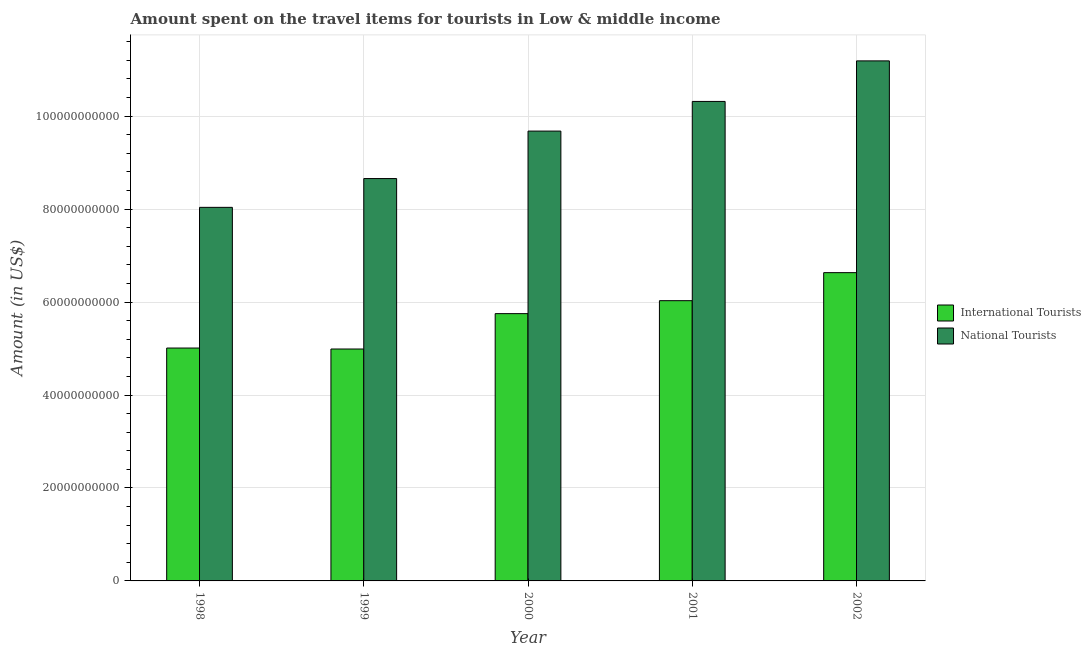What is the label of the 4th group of bars from the left?
Ensure brevity in your answer.  2001. What is the amount spent on travel items of international tourists in 2000?
Offer a terse response. 5.75e+1. Across all years, what is the maximum amount spent on travel items of national tourists?
Keep it short and to the point. 1.12e+11. Across all years, what is the minimum amount spent on travel items of international tourists?
Ensure brevity in your answer.  4.99e+1. In which year was the amount spent on travel items of national tourists minimum?
Offer a terse response. 1998. What is the total amount spent on travel items of international tourists in the graph?
Keep it short and to the point. 2.84e+11. What is the difference between the amount spent on travel items of international tourists in 2000 and that in 2001?
Give a very brief answer. -2.79e+09. What is the difference between the amount spent on travel items of national tourists in 2000 and the amount spent on travel items of international tourists in 2002?
Make the answer very short. -1.51e+1. What is the average amount spent on travel items of international tourists per year?
Provide a short and direct response. 5.68e+1. In the year 2000, what is the difference between the amount spent on travel items of international tourists and amount spent on travel items of national tourists?
Your answer should be very brief. 0. What is the ratio of the amount spent on travel items of national tourists in 1999 to that in 2000?
Offer a very short reply. 0.89. Is the difference between the amount spent on travel items of international tourists in 2000 and 2002 greater than the difference between the amount spent on travel items of national tourists in 2000 and 2002?
Offer a very short reply. No. What is the difference between the highest and the second highest amount spent on travel items of international tourists?
Offer a very short reply. 6.03e+09. What is the difference between the highest and the lowest amount spent on travel items of national tourists?
Offer a very short reply. 3.15e+1. Is the sum of the amount spent on travel items of international tourists in 2000 and 2002 greater than the maximum amount spent on travel items of national tourists across all years?
Your response must be concise. Yes. What does the 2nd bar from the left in 2001 represents?
Ensure brevity in your answer.  National Tourists. What does the 1st bar from the right in 2000 represents?
Make the answer very short. National Tourists. How many bars are there?
Provide a short and direct response. 10. Does the graph contain grids?
Provide a succinct answer. Yes. How are the legend labels stacked?
Your answer should be compact. Vertical. What is the title of the graph?
Your answer should be compact. Amount spent on the travel items for tourists in Low & middle income. What is the label or title of the X-axis?
Your answer should be compact. Year. What is the label or title of the Y-axis?
Make the answer very short. Amount (in US$). What is the Amount (in US$) of International Tourists in 1998?
Provide a short and direct response. 5.01e+1. What is the Amount (in US$) of National Tourists in 1998?
Your response must be concise. 8.04e+1. What is the Amount (in US$) of International Tourists in 1999?
Make the answer very short. 4.99e+1. What is the Amount (in US$) of National Tourists in 1999?
Your answer should be compact. 8.66e+1. What is the Amount (in US$) in International Tourists in 2000?
Offer a terse response. 5.75e+1. What is the Amount (in US$) of National Tourists in 2000?
Your response must be concise. 9.68e+1. What is the Amount (in US$) in International Tourists in 2001?
Make the answer very short. 6.03e+1. What is the Amount (in US$) in National Tourists in 2001?
Offer a very short reply. 1.03e+11. What is the Amount (in US$) in International Tourists in 2002?
Your answer should be compact. 6.63e+1. What is the Amount (in US$) of National Tourists in 2002?
Your answer should be compact. 1.12e+11. Across all years, what is the maximum Amount (in US$) in International Tourists?
Your response must be concise. 6.63e+1. Across all years, what is the maximum Amount (in US$) in National Tourists?
Your answer should be very brief. 1.12e+11. Across all years, what is the minimum Amount (in US$) in International Tourists?
Provide a short and direct response. 4.99e+1. Across all years, what is the minimum Amount (in US$) in National Tourists?
Your answer should be very brief. 8.04e+1. What is the total Amount (in US$) in International Tourists in the graph?
Ensure brevity in your answer.  2.84e+11. What is the total Amount (in US$) of National Tourists in the graph?
Your answer should be compact. 4.79e+11. What is the difference between the Amount (in US$) in International Tourists in 1998 and that in 1999?
Ensure brevity in your answer.  2.08e+08. What is the difference between the Amount (in US$) of National Tourists in 1998 and that in 1999?
Offer a very short reply. -6.20e+09. What is the difference between the Amount (in US$) in International Tourists in 1998 and that in 2000?
Provide a succinct answer. -7.40e+09. What is the difference between the Amount (in US$) of National Tourists in 1998 and that in 2000?
Provide a succinct answer. -1.64e+1. What is the difference between the Amount (in US$) of International Tourists in 1998 and that in 2001?
Your answer should be compact. -1.02e+1. What is the difference between the Amount (in US$) in National Tourists in 1998 and that in 2001?
Your answer should be compact. -2.28e+1. What is the difference between the Amount (in US$) in International Tourists in 1998 and that in 2002?
Offer a very short reply. -1.62e+1. What is the difference between the Amount (in US$) of National Tourists in 1998 and that in 2002?
Offer a very short reply. -3.15e+1. What is the difference between the Amount (in US$) in International Tourists in 1999 and that in 2000?
Make the answer very short. -7.61e+09. What is the difference between the Amount (in US$) in National Tourists in 1999 and that in 2000?
Keep it short and to the point. -1.02e+1. What is the difference between the Amount (in US$) in International Tourists in 1999 and that in 2001?
Offer a terse response. -1.04e+1. What is the difference between the Amount (in US$) of National Tourists in 1999 and that in 2001?
Your response must be concise. -1.66e+1. What is the difference between the Amount (in US$) in International Tourists in 1999 and that in 2002?
Your answer should be compact. -1.64e+1. What is the difference between the Amount (in US$) of National Tourists in 1999 and that in 2002?
Offer a terse response. -2.53e+1. What is the difference between the Amount (in US$) of International Tourists in 2000 and that in 2001?
Keep it short and to the point. -2.79e+09. What is the difference between the Amount (in US$) in National Tourists in 2000 and that in 2001?
Your response must be concise. -6.38e+09. What is the difference between the Amount (in US$) in International Tourists in 2000 and that in 2002?
Ensure brevity in your answer.  -8.82e+09. What is the difference between the Amount (in US$) of National Tourists in 2000 and that in 2002?
Offer a terse response. -1.51e+1. What is the difference between the Amount (in US$) in International Tourists in 2001 and that in 2002?
Make the answer very short. -6.03e+09. What is the difference between the Amount (in US$) of National Tourists in 2001 and that in 2002?
Make the answer very short. -8.73e+09. What is the difference between the Amount (in US$) in International Tourists in 1998 and the Amount (in US$) in National Tourists in 1999?
Keep it short and to the point. -3.65e+1. What is the difference between the Amount (in US$) of International Tourists in 1998 and the Amount (in US$) of National Tourists in 2000?
Keep it short and to the point. -4.67e+1. What is the difference between the Amount (in US$) of International Tourists in 1998 and the Amount (in US$) of National Tourists in 2001?
Your answer should be very brief. -5.31e+1. What is the difference between the Amount (in US$) in International Tourists in 1998 and the Amount (in US$) in National Tourists in 2002?
Ensure brevity in your answer.  -6.18e+1. What is the difference between the Amount (in US$) of International Tourists in 1999 and the Amount (in US$) of National Tourists in 2000?
Your response must be concise. -4.69e+1. What is the difference between the Amount (in US$) of International Tourists in 1999 and the Amount (in US$) of National Tourists in 2001?
Offer a very short reply. -5.33e+1. What is the difference between the Amount (in US$) in International Tourists in 1999 and the Amount (in US$) in National Tourists in 2002?
Your response must be concise. -6.20e+1. What is the difference between the Amount (in US$) in International Tourists in 2000 and the Amount (in US$) in National Tourists in 2001?
Keep it short and to the point. -4.57e+1. What is the difference between the Amount (in US$) of International Tourists in 2000 and the Amount (in US$) of National Tourists in 2002?
Ensure brevity in your answer.  -5.44e+1. What is the difference between the Amount (in US$) in International Tourists in 2001 and the Amount (in US$) in National Tourists in 2002?
Your answer should be compact. -5.16e+1. What is the average Amount (in US$) in International Tourists per year?
Offer a terse response. 5.68e+1. What is the average Amount (in US$) in National Tourists per year?
Ensure brevity in your answer.  9.58e+1. In the year 1998, what is the difference between the Amount (in US$) in International Tourists and Amount (in US$) in National Tourists?
Provide a short and direct response. -3.03e+1. In the year 1999, what is the difference between the Amount (in US$) in International Tourists and Amount (in US$) in National Tourists?
Provide a succinct answer. -3.67e+1. In the year 2000, what is the difference between the Amount (in US$) of International Tourists and Amount (in US$) of National Tourists?
Give a very brief answer. -3.93e+1. In the year 2001, what is the difference between the Amount (in US$) in International Tourists and Amount (in US$) in National Tourists?
Give a very brief answer. -4.29e+1. In the year 2002, what is the difference between the Amount (in US$) in International Tourists and Amount (in US$) in National Tourists?
Provide a short and direct response. -4.56e+1. What is the ratio of the Amount (in US$) in National Tourists in 1998 to that in 1999?
Your answer should be compact. 0.93. What is the ratio of the Amount (in US$) of International Tourists in 1998 to that in 2000?
Give a very brief answer. 0.87. What is the ratio of the Amount (in US$) of National Tourists in 1998 to that in 2000?
Give a very brief answer. 0.83. What is the ratio of the Amount (in US$) in International Tourists in 1998 to that in 2001?
Keep it short and to the point. 0.83. What is the ratio of the Amount (in US$) in National Tourists in 1998 to that in 2001?
Your response must be concise. 0.78. What is the ratio of the Amount (in US$) in International Tourists in 1998 to that in 2002?
Your answer should be compact. 0.76. What is the ratio of the Amount (in US$) of National Tourists in 1998 to that in 2002?
Keep it short and to the point. 0.72. What is the ratio of the Amount (in US$) in International Tourists in 1999 to that in 2000?
Give a very brief answer. 0.87. What is the ratio of the Amount (in US$) in National Tourists in 1999 to that in 2000?
Your answer should be very brief. 0.89. What is the ratio of the Amount (in US$) in International Tourists in 1999 to that in 2001?
Ensure brevity in your answer.  0.83. What is the ratio of the Amount (in US$) of National Tourists in 1999 to that in 2001?
Make the answer very short. 0.84. What is the ratio of the Amount (in US$) in International Tourists in 1999 to that in 2002?
Provide a short and direct response. 0.75. What is the ratio of the Amount (in US$) in National Tourists in 1999 to that in 2002?
Ensure brevity in your answer.  0.77. What is the ratio of the Amount (in US$) of International Tourists in 2000 to that in 2001?
Give a very brief answer. 0.95. What is the ratio of the Amount (in US$) of National Tourists in 2000 to that in 2001?
Keep it short and to the point. 0.94. What is the ratio of the Amount (in US$) in International Tourists in 2000 to that in 2002?
Offer a terse response. 0.87. What is the ratio of the Amount (in US$) in National Tourists in 2000 to that in 2002?
Provide a succinct answer. 0.86. What is the ratio of the Amount (in US$) of National Tourists in 2001 to that in 2002?
Offer a very short reply. 0.92. What is the difference between the highest and the second highest Amount (in US$) of International Tourists?
Keep it short and to the point. 6.03e+09. What is the difference between the highest and the second highest Amount (in US$) in National Tourists?
Ensure brevity in your answer.  8.73e+09. What is the difference between the highest and the lowest Amount (in US$) in International Tourists?
Offer a very short reply. 1.64e+1. What is the difference between the highest and the lowest Amount (in US$) of National Tourists?
Your answer should be very brief. 3.15e+1. 